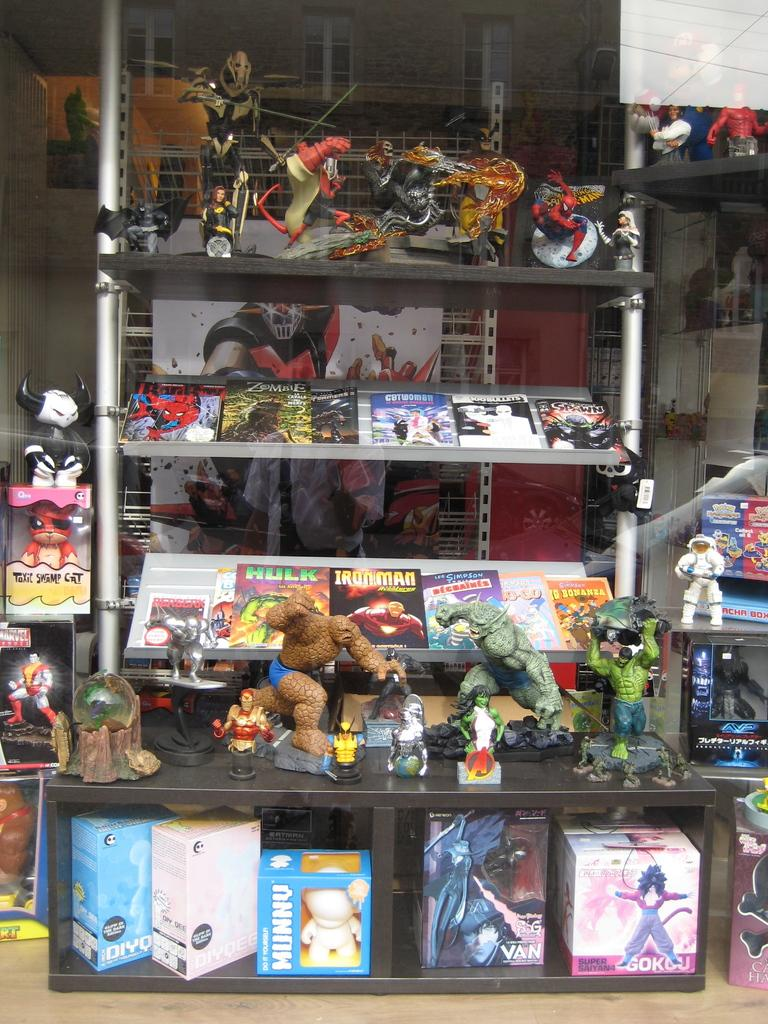Provide a one-sentence caption for the provided image. A box on the lower shelf on the right side says Gokou. 